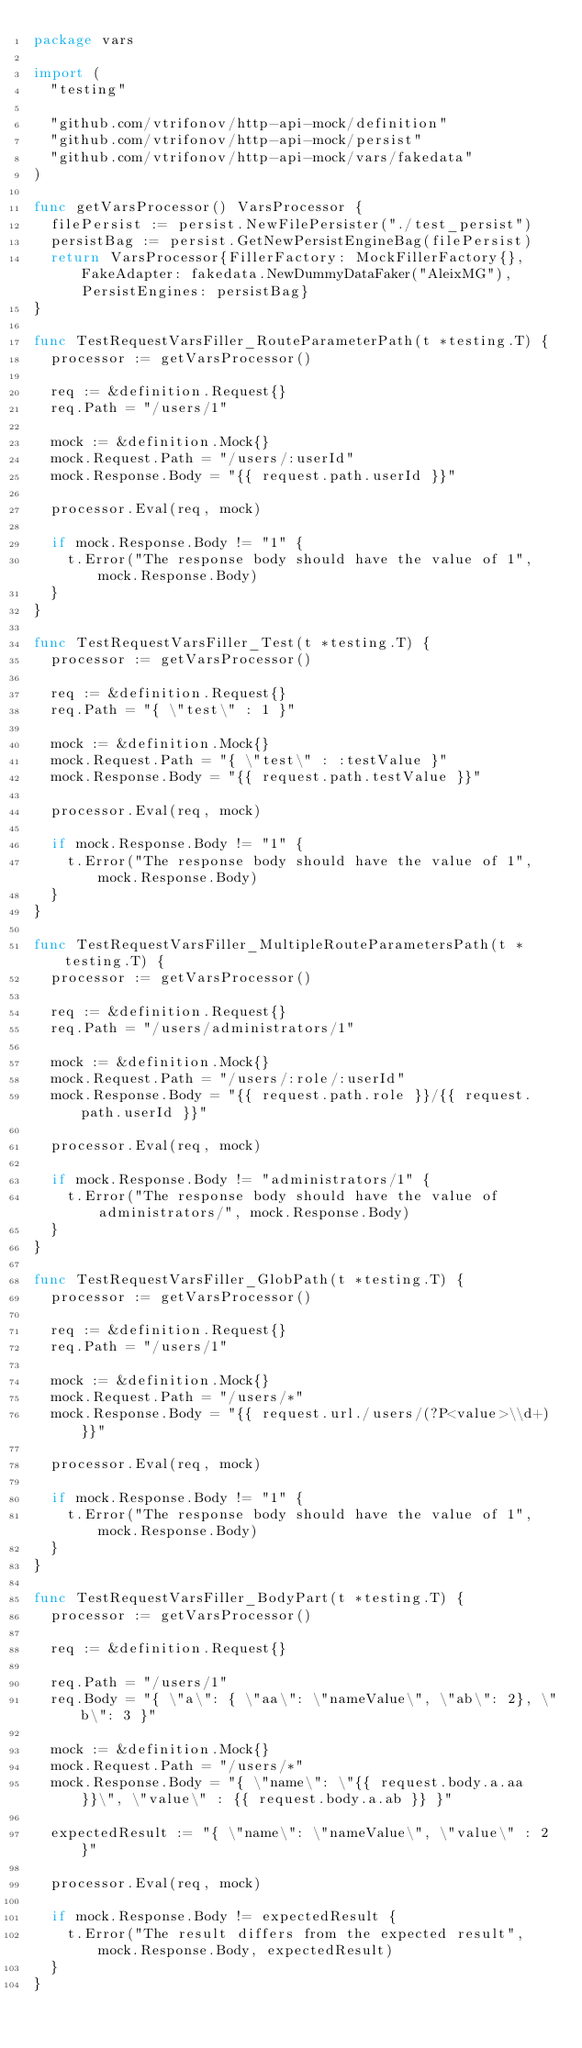Convert code to text. <code><loc_0><loc_0><loc_500><loc_500><_Go_>package vars

import (
	"testing"

	"github.com/vtrifonov/http-api-mock/definition"
	"github.com/vtrifonov/http-api-mock/persist"
	"github.com/vtrifonov/http-api-mock/vars/fakedata"
)

func getVarsProcessor() VarsProcessor {
	filePersist := persist.NewFilePersister("./test_persist")
	persistBag := persist.GetNewPersistEngineBag(filePersist)
	return VarsProcessor{FillerFactory: MockFillerFactory{}, FakeAdapter: fakedata.NewDummyDataFaker("AleixMG"), PersistEngines: persistBag}
}

func TestRequestVarsFiller_RouteParameterPath(t *testing.T) {
	processor := getVarsProcessor()

	req := &definition.Request{}
	req.Path = "/users/1"

	mock := &definition.Mock{}
	mock.Request.Path = "/users/:userId"
	mock.Response.Body = "{{ request.path.userId }}"

	processor.Eval(req, mock)

	if mock.Response.Body != "1" {
		t.Error("The response body should have the value of 1", mock.Response.Body)
	}
}

func TestRequestVarsFiller_Test(t *testing.T) {
	processor := getVarsProcessor()

	req := &definition.Request{}
	req.Path = "{ \"test\" : 1 }"

	mock := &definition.Mock{}
	mock.Request.Path = "{ \"test\" : :testValue }"
	mock.Response.Body = "{{ request.path.testValue }}"

	processor.Eval(req, mock)

	if mock.Response.Body != "1" {
		t.Error("The response body should have the value of 1", mock.Response.Body)
	}
}

func TestRequestVarsFiller_MultipleRouteParametersPath(t *testing.T) {
	processor := getVarsProcessor()

	req := &definition.Request{}
	req.Path = "/users/administrators/1"

	mock := &definition.Mock{}
	mock.Request.Path = "/users/:role/:userId"
	mock.Response.Body = "{{ request.path.role }}/{{ request.path.userId }}"

	processor.Eval(req, mock)

	if mock.Response.Body != "administrators/1" {
		t.Error("The response body should have the value of administrators/", mock.Response.Body)
	}
}

func TestRequestVarsFiller_GlobPath(t *testing.T) {
	processor := getVarsProcessor()

	req := &definition.Request{}
	req.Path = "/users/1"

	mock := &definition.Mock{}
	mock.Request.Path = "/users/*"
	mock.Response.Body = "{{ request.url./users/(?P<value>\\d+) }}"

	processor.Eval(req, mock)

	if mock.Response.Body != "1" {
		t.Error("The response body should have the value of 1", mock.Response.Body)
	}
}

func TestRequestVarsFiller_BodyPart(t *testing.T) {
	processor := getVarsProcessor()

	req := &definition.Request{}

	req.Path = "/users/1"
	req.Body = "{ \"a\": { \"aa\": \"nameValue\", \"ab\": 2}, \"b\": 3 }"

	mock := &definition.Mock{}
	mock.Request.Path = "/users/*"
	mock.Response.Body = "{ \"name\": \"{{ request.body.a.aa }}\", \"value\" : {{ request.body.a.ab }} }"

	expectedResult := "{ \"name\": \"nameValue\", \"value\" : 2 }"

	processor.Eval(req, mock)

	if mock.Response.Body != expectedResult {
		t.Error("The result differs from the expected result", mock.Response.Body, expectedResult)
	}
}
</code> 